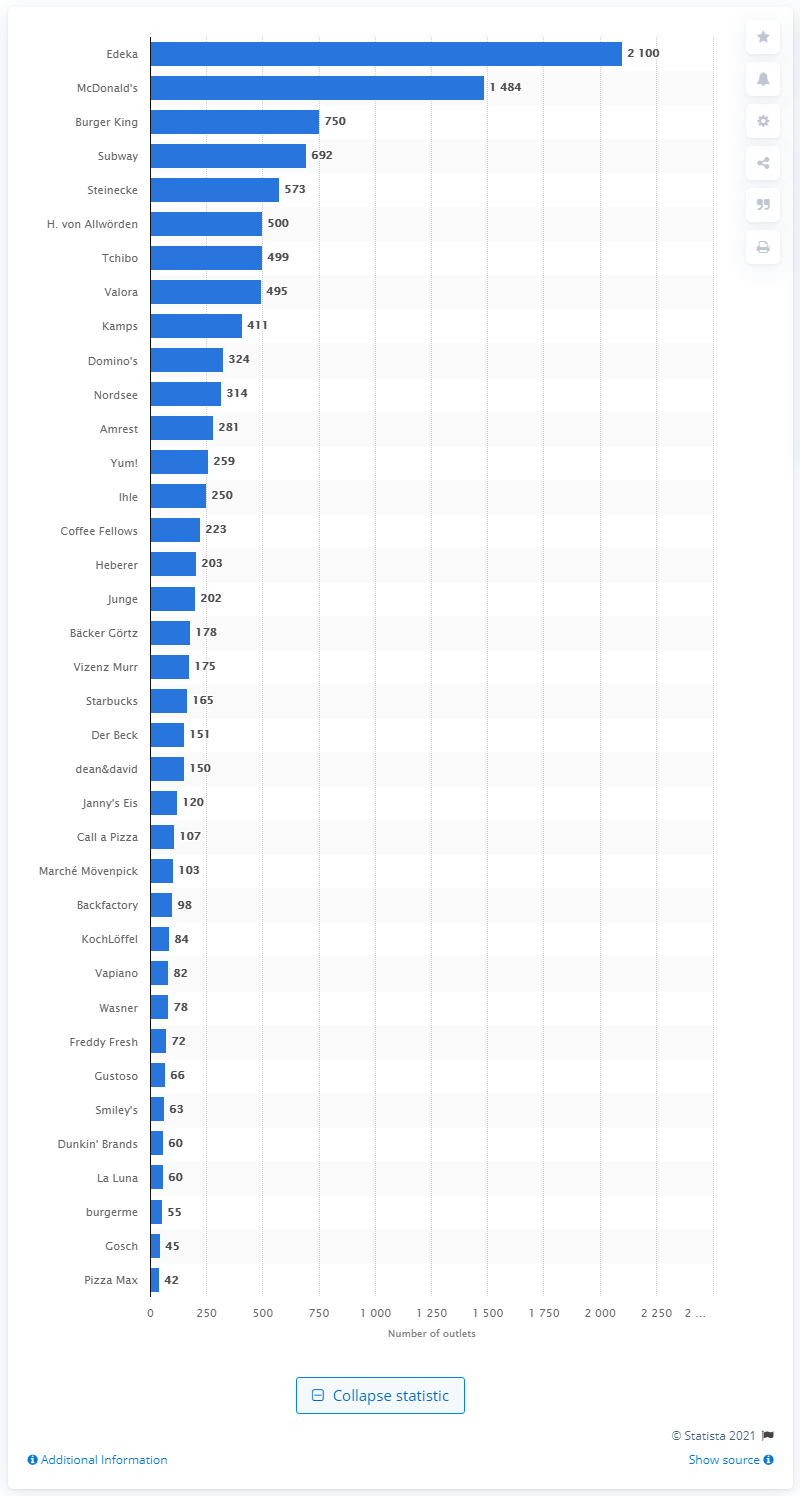Highlight a few significant elements in this photo. In 2019, Edeka was the fast food chain with the highest number of outlets in Germany. 